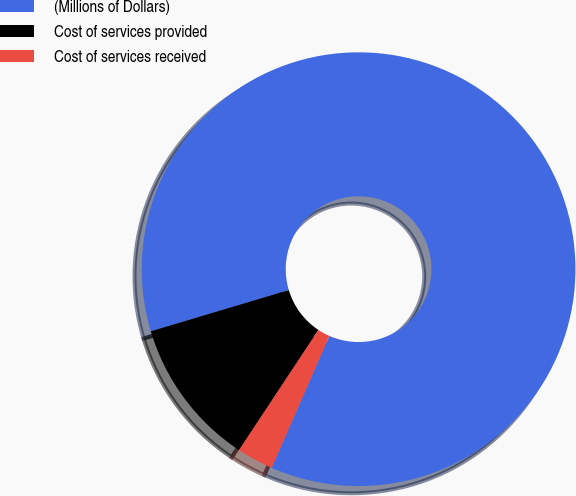Convert chart. <chart><loc_0><loc_0><loc_500><loc_500><pie_chart><fcel>(Millions of Dollars)<fcel>Cost of services provided<fcel>Cost of services received<nl><fcel>86.19%<fcel>11.08%<fcel>2.73%<nl></chart> 